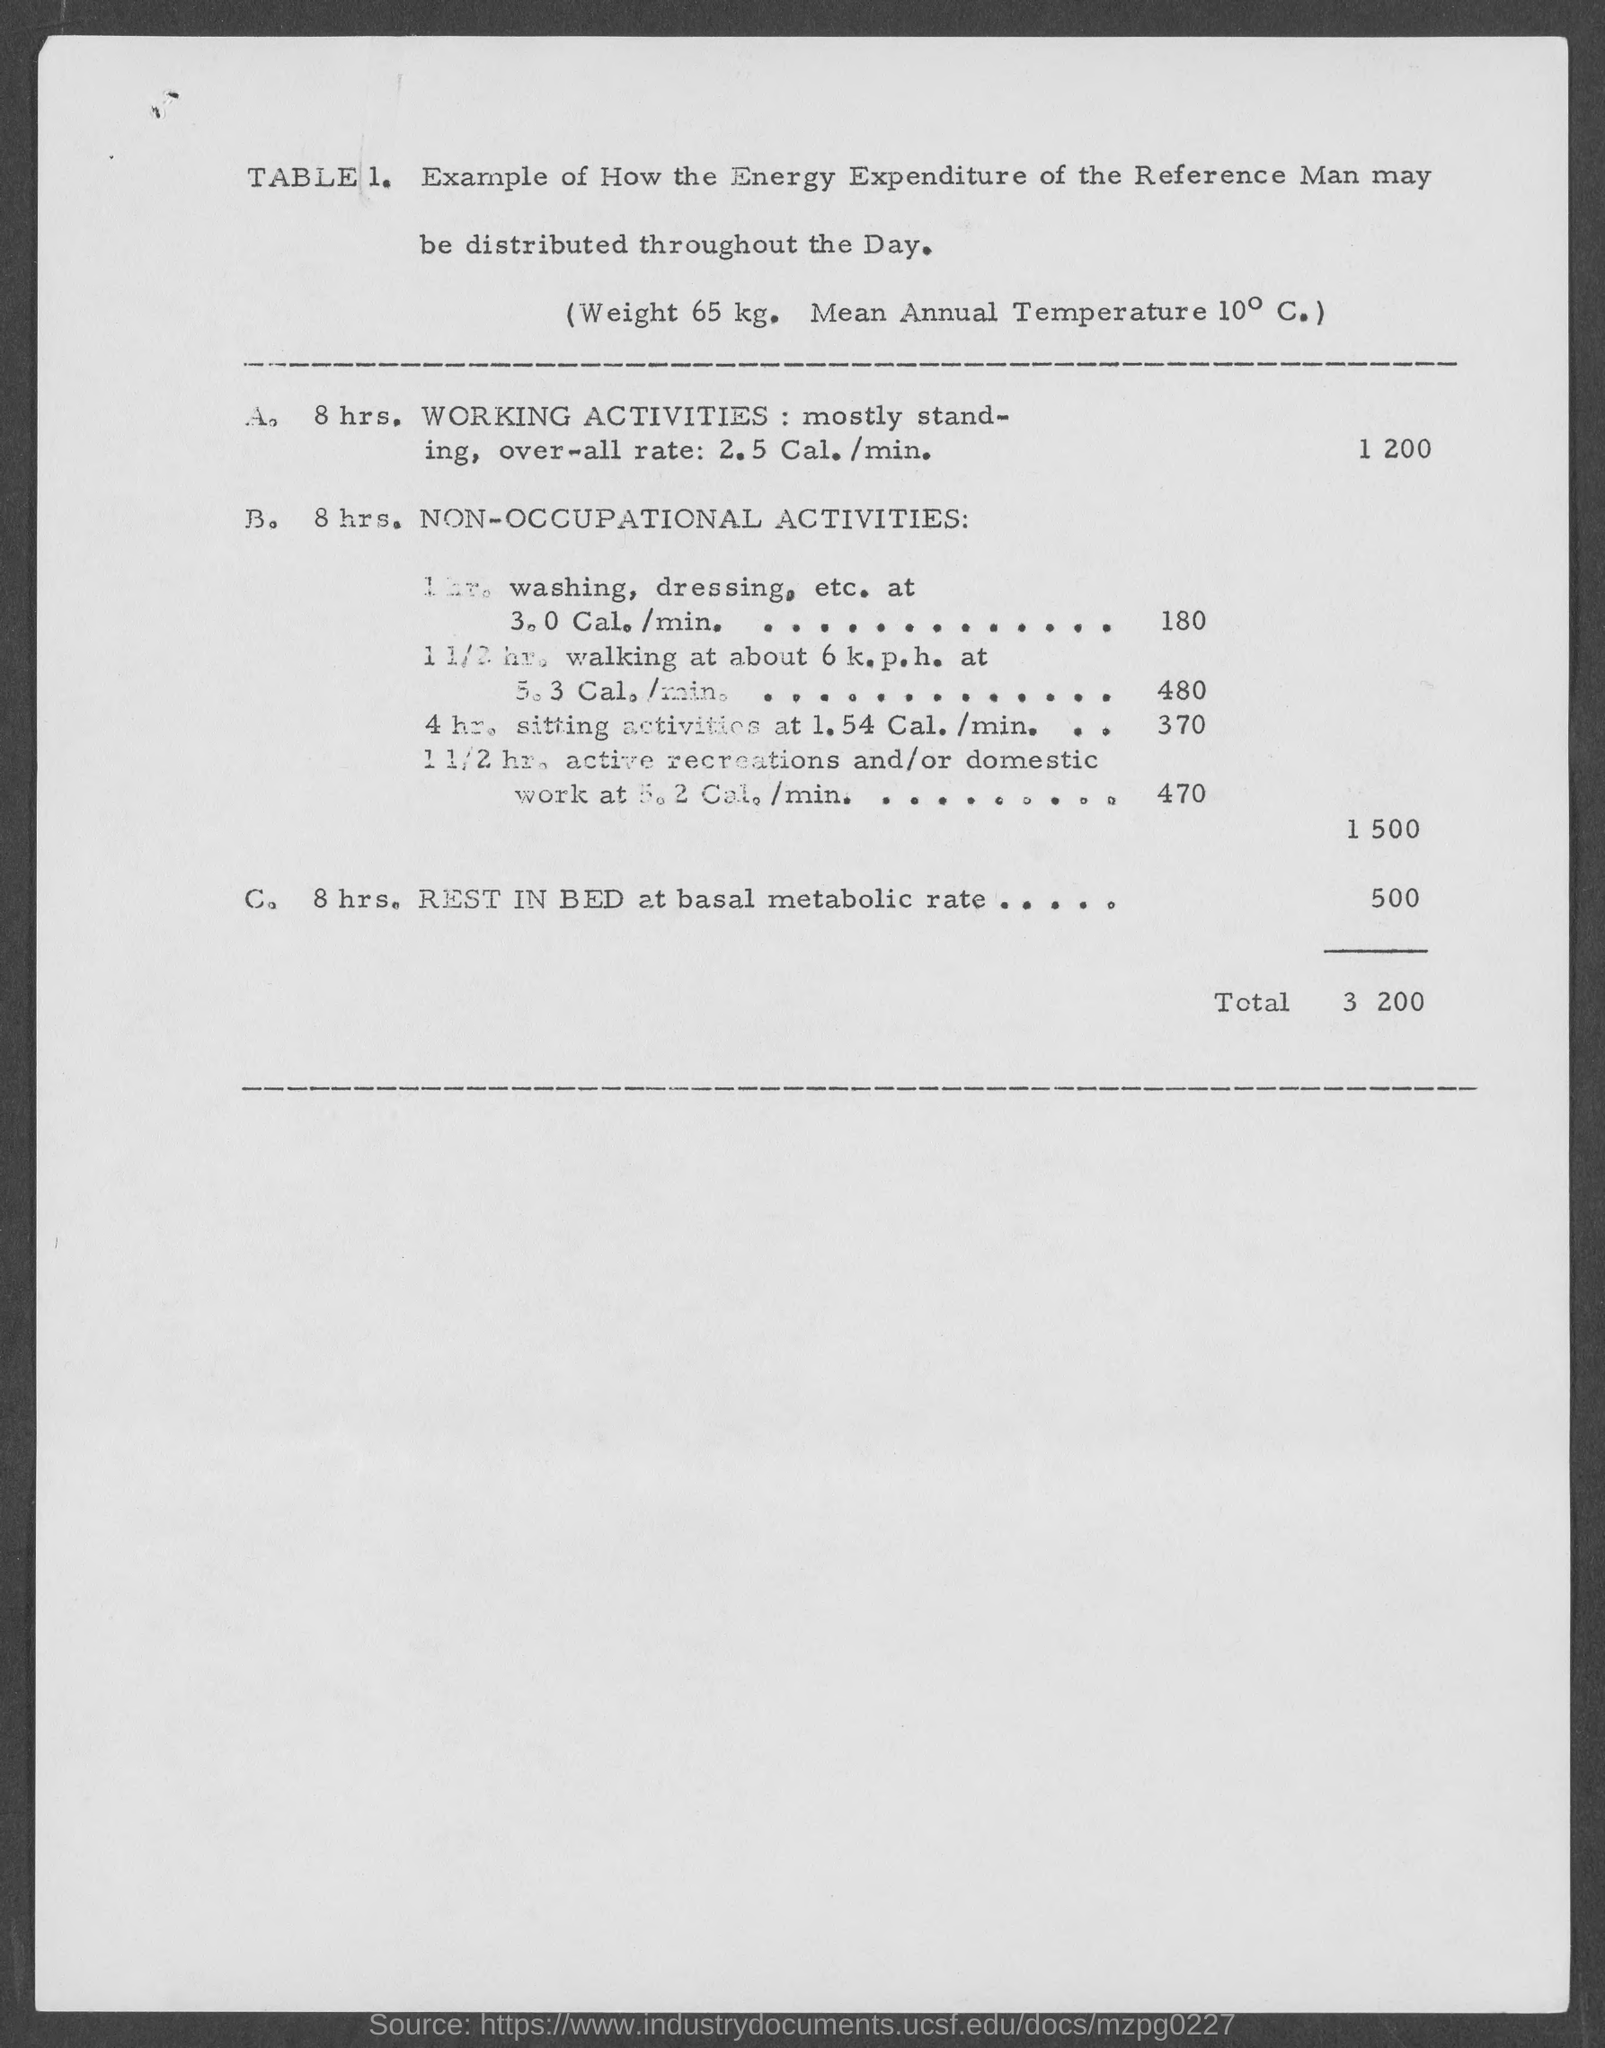Highlight a few significant elements in this photo. The total amount is 3,200. 